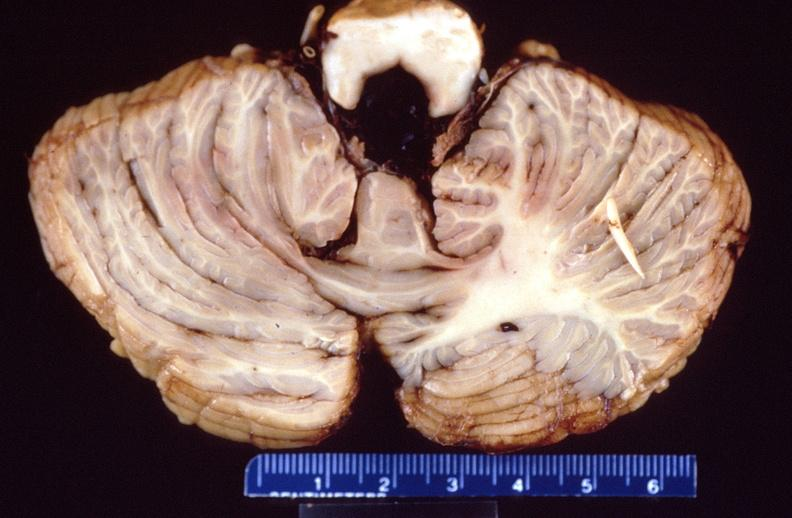s band constriction in skin above ankle of infant present?
Answer the question using a single word or phrase. No 